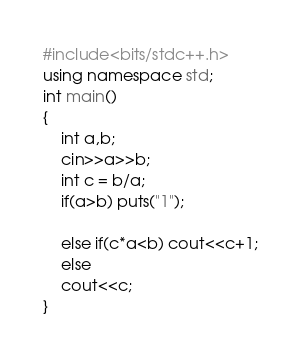<code> <loc_0><loc_0><loc_500><loc_500><_C++_>
#include<bits/stdc++.h>
using namespace std;
int main()
{
    int a,b;
    cin>>a>>b;
    int c = b/a;
    if(a>b) puts("1");

    else if(c*a<b) cout<<c+1;
    else
    cout<<c;
}

</code> 